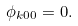<formula> <loc_0><loc_0><loc_500><loc_500>\phi _ { k 0 0 } = 0 .</formula> 